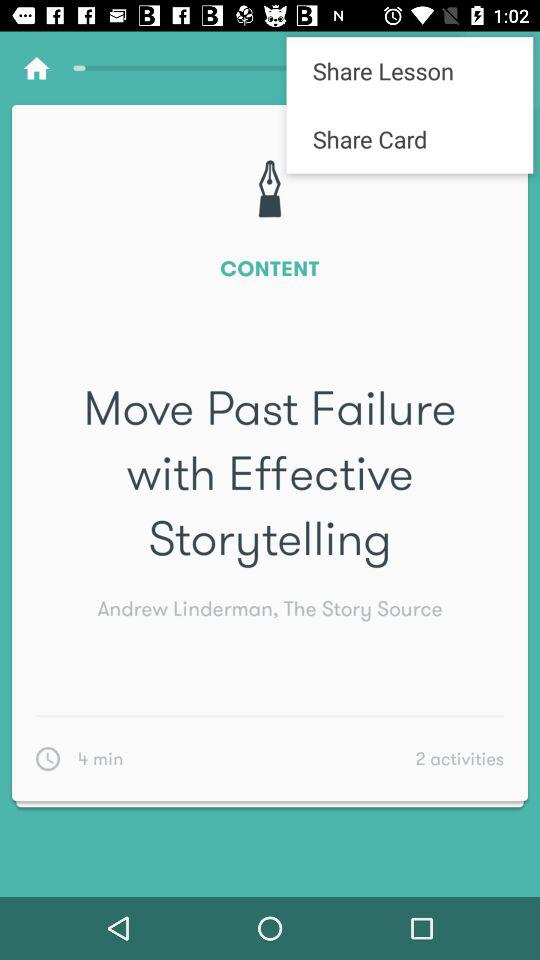What is the number of activities? The number of activities is 2. 